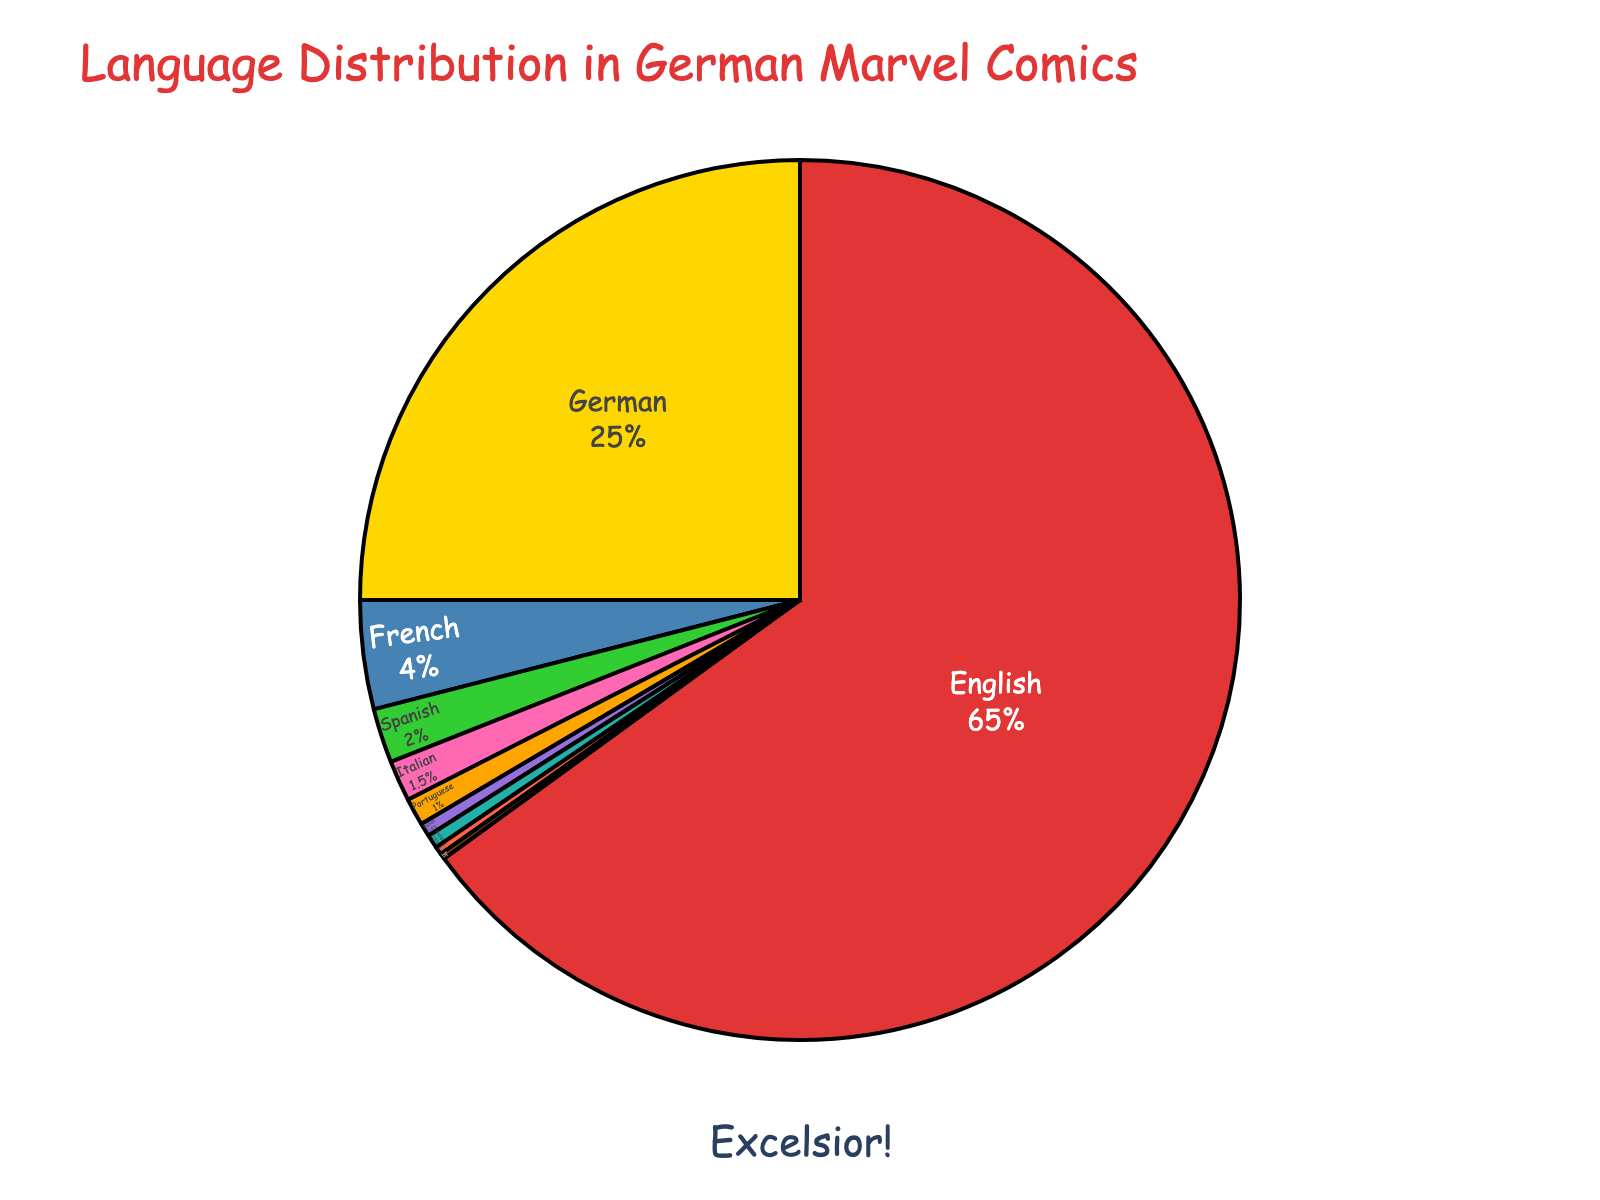What language has the highest percentage of translation? Looking at the pie chart, the largest segment corresponds to English. The label indicates a percentage of 65%.
Answer: English How much larger is the percentage of English translations compared to German translations? The chart shows that English translations account for 65% and German translations for 25%. Subtracting these two values: 65% - 25% = 40%
Answer: 40% What is the percentage of translations in Italian and Portuguese combined? According to the chart, Italian translations account for 1.5% and Portuguese translations for 1%. Adding these two percentages: 1.5% + 1% = 2.5%
Answer: 2.5% Among the non-English translations, which language has the highest percentage? Ignoring the English portion, the next largest segment in the pie chart is for German translations, which is 25%.
Answer: German Which languages have less than 1% of the translations? The chart shows segments with less than 1% for Portuguese (1%), Dutch (0.5%), Polish (0.5%), Swedish (0.3%), and Danish (0.2%).
Answer: Portuguese, Dutch, Polish, Swedish, Danish What is the percentage difference between French and Spanish translations? The pie chart indicates that French translations account for 4% and Spanish translations for 2%. Subtracting these two values: 4% - 2% = 2%
Answer: 2% What color represents the German translations in the pie chart? The segment representing German translations is colored gold in the chart.
Answer: Gold Which two languages have the smallest percentages of translations? According to the pie chart, the two smallest segments are Swedish (0.3%) and Danish (0.2%).
Answer: Swedish, Danish What is the combined percentage of translations for English, German, and French? The chart shows the following percentages: English (65%), German (25%), and French (4%). Adding these three values: 65% + 25% + 4% = 94%
Answer: 94% Which language has a higher percentage of translations, Italian or Spanish? According to the pie chart, Spanish translations account for 2%, while Italian translations account for 1.5%. 2% is greater than 1.5%.
Answer: Spanish 